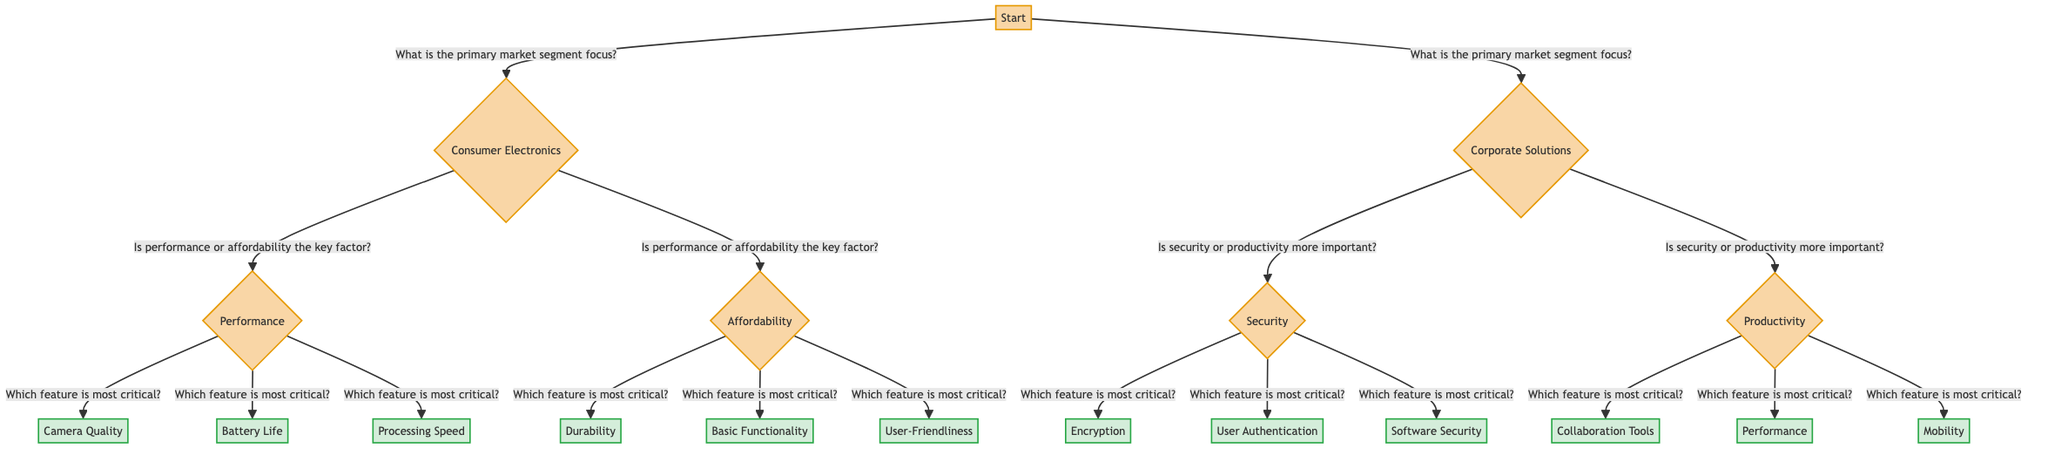What is the root question in the diagram? The root question is about the primary market segment focus, which divides the diagram into two main branches: Consumer Electronics and Corporate Solutions.
Answer: What is the primary market segment focus? How many options are available for the Consumer Electronics market segment? In the Consumer Electronics segment, there are two options: Performance and Affordability.
Answer: 2 Which feature is prioritized if the focus is on Corporate Solutions and security is deemed more important? If security is the priority in Corporate Solutions, the next question is about the most critical feature, allowing options like Encryption, User Authentication, and Software Security.
Answer: Which feature is most critical? What action is suggested for the feature "Battery Life" under Performance? The action suggested for Battery Life is to focus on long-lasting batteries and fast charging capabilities.
Answer: Focus on long-lasting batteries and fast charging capabilities How many total actions are described in the diagram? There are a total of 9 actions described in the diagram, corresponding to the three feature priorities under each initial category.
Answer: 9 What are the two main paths if affordability is the primary factor in Consumer Electronics? If affordability is the primary factor, the two critical features to consider are Durability and User-Friendliness, leading to actions that highlight build quality and ease of use.
Answer: Durability and User-Friendliness What feature would be emphasized for corporate clients focusing on productivity? For corporate clients focusing on productivity, the most critical feature to emphasize is high performance and multitasking capabilities.
Answer: High performance and multitasking capabilities What is the relationship between performance focus and the feature prioritization in the diagram? The performance focus leads to a specific question about which feature is most critical, branching into options like Camera Quality and Processing Speed for prioritization.
Answer: Leads to feature prioritization What would be the outcome if a client prioritizes User-Friendliness in Consumer Electronics? If a client prioritizes User-Friendliness, the recommended action would emphasize ease of use and seamless integration with other devices.
Answer: Emphasize ease of use and seamless integration with other devices 